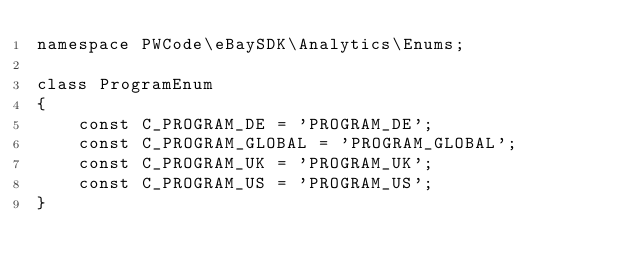<code> <loc_0><loc_0><loc_500><loc_500><_PHP_>namespace PWCode\eBaySDK\Analytics\Enums;

class ProgramEnum
{
    const C_PROGRAM_DE = 'PROGRAM_DE';
    const C_PROGRAM_GLOBAL = 'PROGRAM_GLOBAL';
    const C_PROGRAM_UK = 'PROGRAM_UK';
    const C_PROGRAM_US = 'PROGRAM_US';
}
</code> 